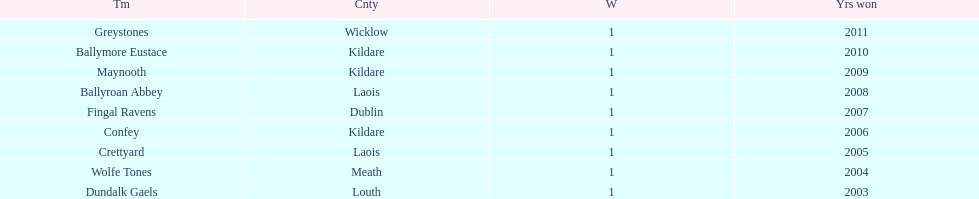How many wins did confey have? 1. 